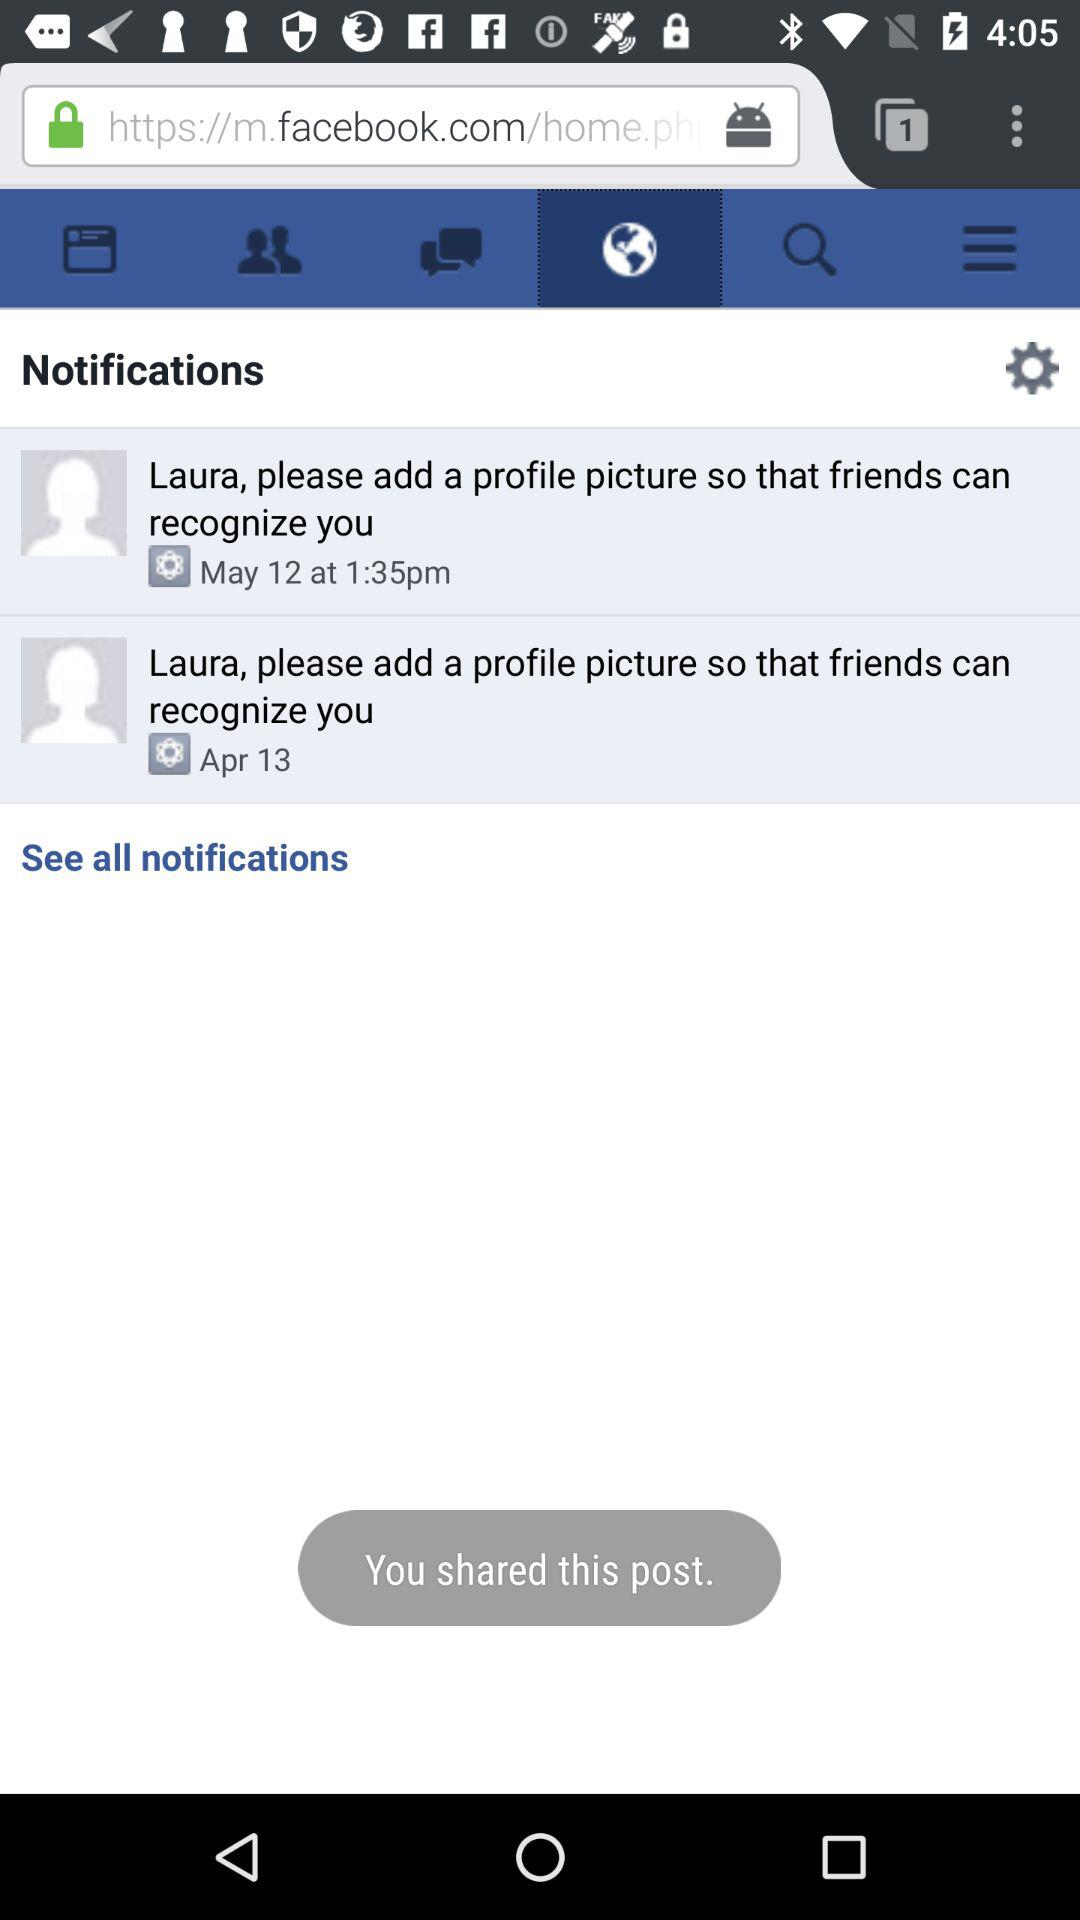How many tabs are open? There is 1 open tab. 